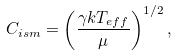<formula> <loc_0><loc_0><loc_500><loc_500>C _ { i s m } = \left ( \frac { \gamma k T _ { e f f } } { \mu } \right ) ^ { 1 / 2 } ,</formula> 